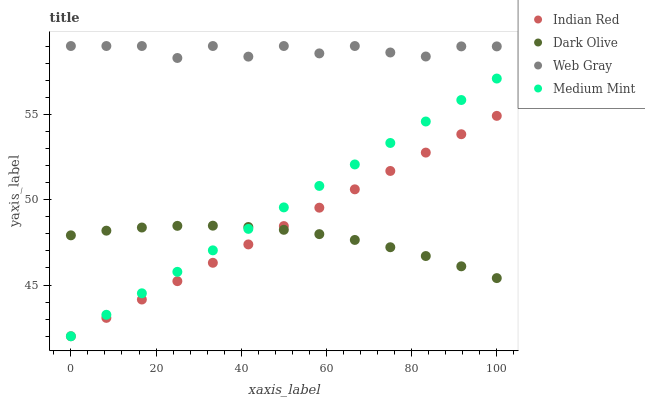Does Dark Olive have the minimum area under the curve?
Answer yes or no. Yes. Does Web Gray have the maximum area under the curve?
Answer yes or no. Yes. Does Web Gray have the minimum area under the curve?
Answer yes or no. No. Does Dark Olive have the maximum area under the curve?
Answer yes or no. No. Is Medium Mint the smoothest?
Answer yes or no. Yes. Is Web Gray the roughest?
Answer yes or no. Yes. Is Dark Olive the smoothest?
Answer yes or no. No. Is Dark Olive the roughest?
Answer yes or no. No. Does Medium Mint have the lowest value?
Answer yes or no. Yes. Does Dark Olive have the lowest value?
Answer yes or no. No. Does Web Gray have the highest value?
Answer yes or no. Yes. Does Dark Olive have the highest value?
Answer yes or no. No. Is Indian Red less than Web Gray?
Answer yes or no. Yes. Is Web Gray greater than Medium Mint?
Answer yes or no. Yes. Does Indian Red intersect Dark Olive?
Answer yes or no. Yes. Is Indian Red less than Dark Olive?
Answer yes or no. No. Is Indian Red greater than Dark Olive?
Answer yes or no. No. Does Indian Red intersect Web Gray?
Answer yes or no. No. 